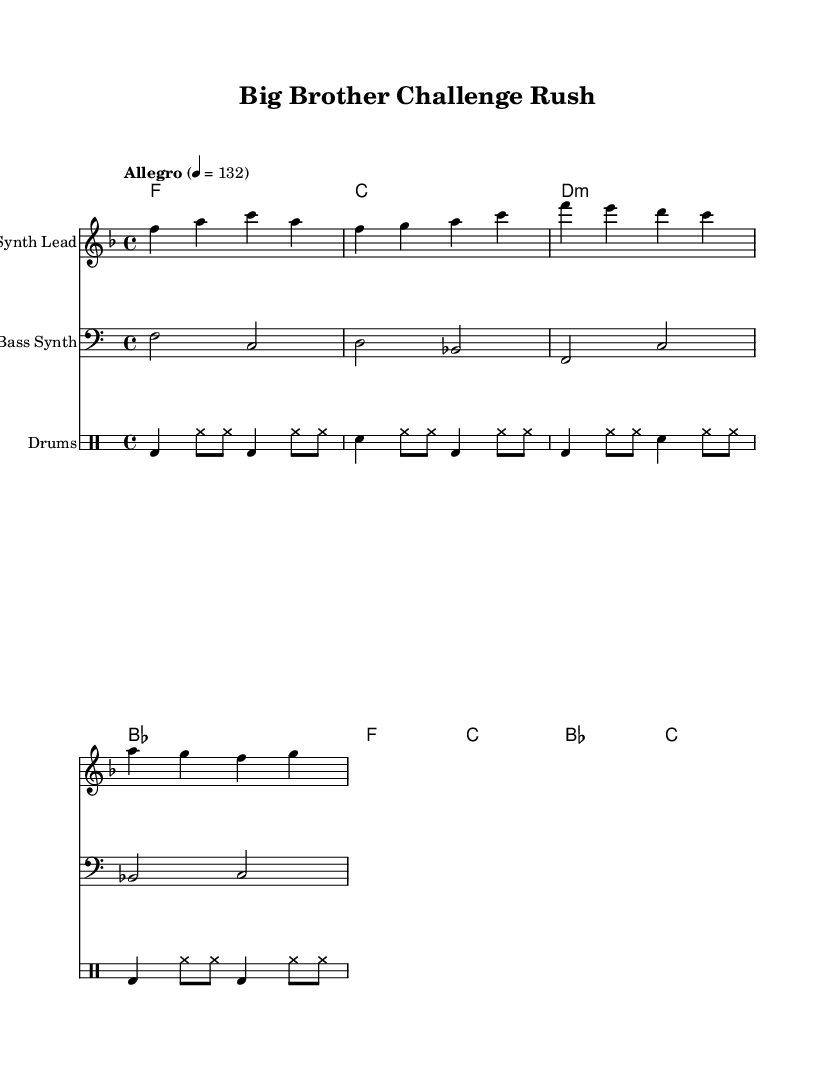What is the key signature of this music? The key signature is F major, which has one flat (B flat).
Answer: F major What is the time signature of this music? The time signature is 4/4, indicating four beats per measure.
Answer: 4/4 What is the tempo marking for this piece? The tempo marking is "Allegro" with a beats per minute of 132.
Answer: Allegro 4 = 132 How many measures are in the melody section? There are four measures in the melody section as indicated by the notation.
Answer: 4 What type of chords are used in the harmony section? The harmony section includes major and minor chords, such as F major, C major, and D minor.
Answer: Major and minor Which instrument is primarily playing the melody? The melody is primarily played by a "Synth Lead" in the score as indicated in the staff heading.
Answer: Synth Lead What rhythmic pattern does the bass follow? The bass follows a simple rhythm with a combination of quarter and half notes primarily.
Answer: Simple rhythm 